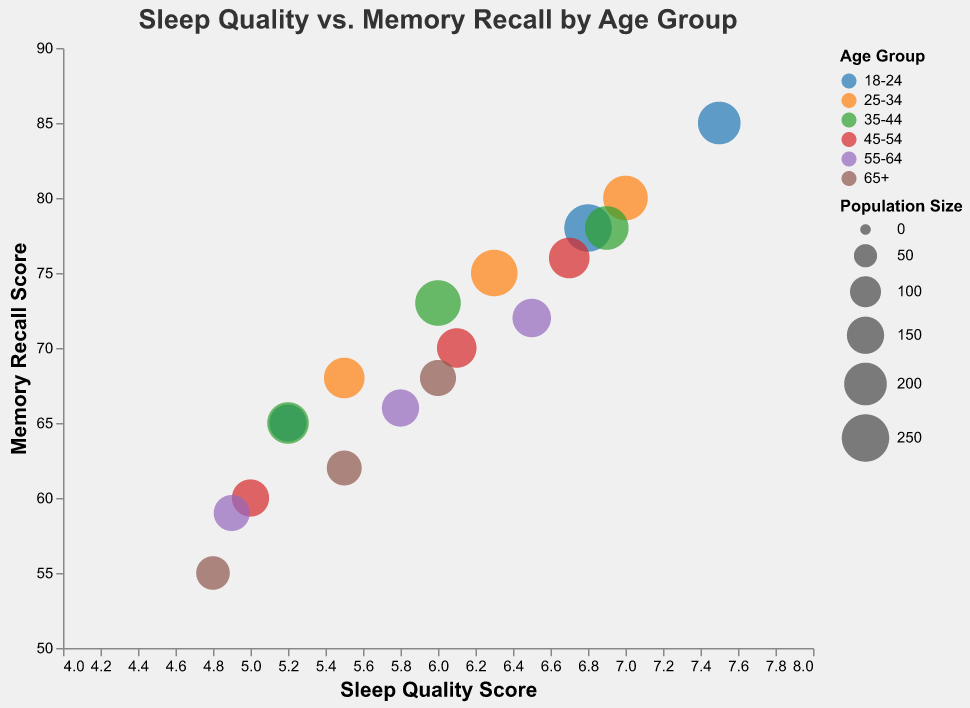What's the title of the bubble chart? The title of a chart is often at the top and serves as a summary of the visualized data. Looking at the figure, you can see the title as "Sleep Quality vs. Memory Recall by Age Group".
Answer: Sleep Quality vs. Memory Recall by Age Group Which axis represents the Memory Recall Scores? Typically, axes are labeled to indicate what data they represent. In the figure, the y-axis label is "Memory Recall Score", which confirms that this axis represents Memory Recall Scores.
Answer: y-axis Which age group has the data point with the highest Sleep Quality Score? To determine this, look for the point farthest to the right on the x-axis, as this axis represents Sleep Quality Score. The highest Sleep Quality Score is 7.5, which belongs to the age group 18-24.
Answer: 18-24 Which age group has the largest bubble size in the chart? The size of the bubbles represents population size. The largest bubble will visually appear the biggest. Observing the chart, the largest bubble, representing a population size of 250, belongs to the age group 18-24.
Answer: 18-24 What is the Sleep Quality Score range represented in the bubble chart? The x-axis represents Sleep Quality Scores, which range from around 4 to 8.
Answer: 4 to 8 Compare the Memory Recall Scores for age groups 25-34 and 65+ that have a Sleep Quality Score of 5.5. Which one is higher? Find the points where the Sleep Quality Score is 5.5 for both age groups. The Memory Recall Score for the 25-34 group is 68, and for the 65+ group is 62. Therefore, the 25-34 group has a higher score.
Answer: 25-34 Which age group has the lowest Memory Recall Score? To find the lowest Memory Recall Score, look for the point closest to the bottom on the y-axis. The score of 55, the lowest value, belongs to the age group 65+.
Answer: 65+ What is the average Memory Recall Score for the age group 45-54? From the data for age group 45-54: 76, 70, and 60. The sum is 76 + 70 + 60 = 206. There are 3 data points, so the average is 206 / 3 ≈ 68.67.
Answer: 68.67 How does the relationship between Sleep Quality and Memory Recall appear in the chart? By analyzing the scatter of data points, it is visible that both Sleep Quality and Memory Recall seem to have a positive correlation; as Sleep Quality increases, Memory Recall also tends to increase.
Answer: Positive correlation Which age group exhibits the most consistent Sleep Quality Scores? Consistency can be seen from the spread of the Sleep Quality Score points. The 18-24 age group shows the least spread in their scores (ranging from 5.2 to 7.5), implying more consistent scores compared to other age groups.
Answer: 18-24 